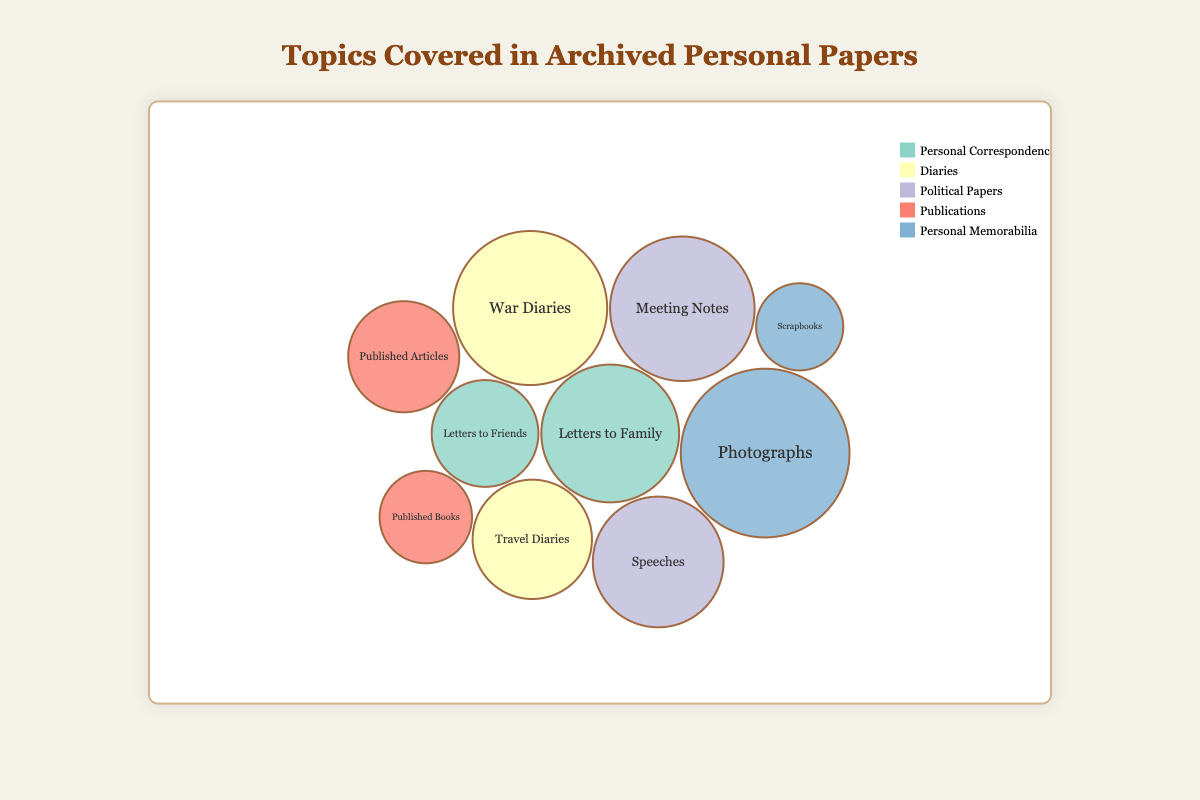What is the topic with the highest volume of personal papers? To find this, look for the largest bubble size and check the corresponding topic label. The largest bubble represents "Photographs" under the topic "Personal Memorabilia" with a volume of 300.
Answer: Personal Memorabilia Which subject under "Political Papers" has a higher volume, "Speeches" or "Meeting Notes"? Compare the sizes of the two bubbles representing "Speeches" and "Meeting Notes" under "Political Papers". "Meeting Notes" has a higher volume (220) than "Speeches" (180).
Answer: Meeting Notes What is the total volume of all the diaries combined? Add the volumes for "Travel Diaries" (150) and "War Diaries" (250) under the Diaries topic. 150 + 250 = 400.
Answer: 400 Is the volume of "Letters to Family" greater than "Photographs"? Compare the bubbles for "Letters to Family" (200) under Personal Correspondence and "Photographs" (300) under Personal Memorabilia. "Photographs" is larger.
Answer: No How many subjects are listed under "Publications"? Count the bubbles under the "Publications" topic. There's "Published Books" and "Published Articles", making a total of 2 subjects.
Answer: 2 Which subject under "Diaries" has a larger volume, "Travel Diaries" or "War Diaries"? Compare the bubble sizes of "Travel Diaries" (150) and "War Diaries" (250) under "Diaries". "War Diaries" has a larger volume.
Answer: War Diaries Which topic has the smallest volume overall? Identify the smallest bubble in the chart. The smallest bubble is "Scrapbooks" under Personal Memorabilia with a volume of 80.
Answer: Personal Memorabilia What is the combined volume of "Political Papers" and "Publications"? Sum the volumes of all subjects under "Political Papers" (180 + 220) and "Publications" (90 + 130). 180 + 220 + 90 + 130 = 620.
Answer: 620 